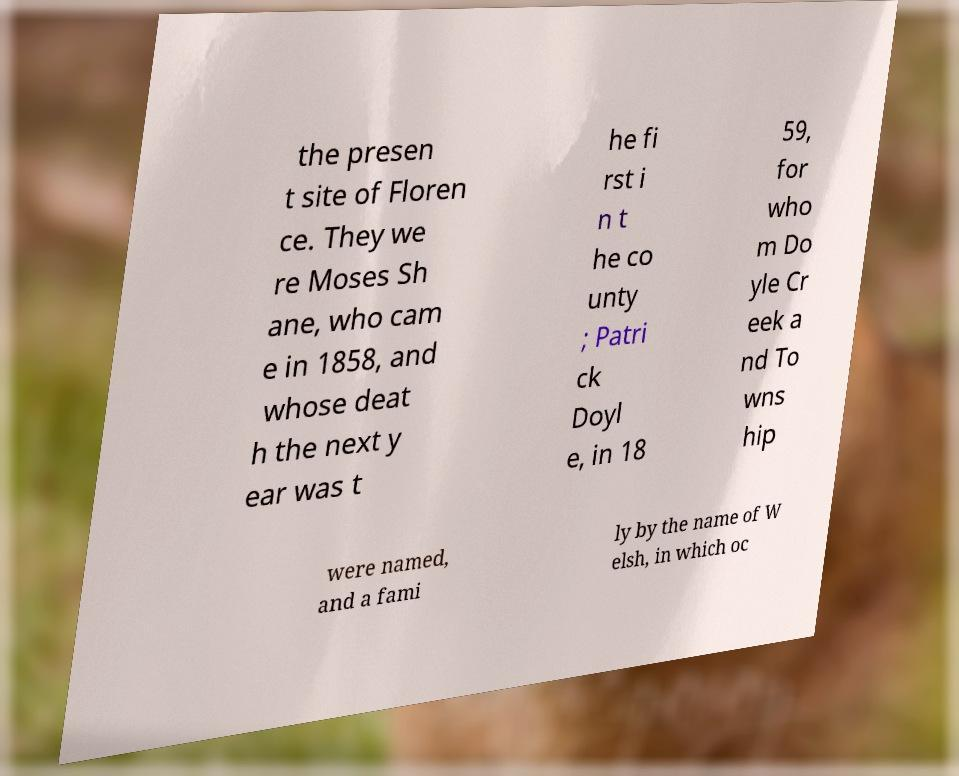For documentation purposes, I need the text within this image transcribed. Could you provide that? the presen t site of Floren ce. They we re Moses Sh ane, who cam e in 1858, and whose deat h the next y ear was t he fi rst i n t he co unty ; Patri ck Doyl e, in 18 59, for who m Do yle Cr eek a nd To wns hip were named, and a fami ly by the name of W elsh, in which oc 